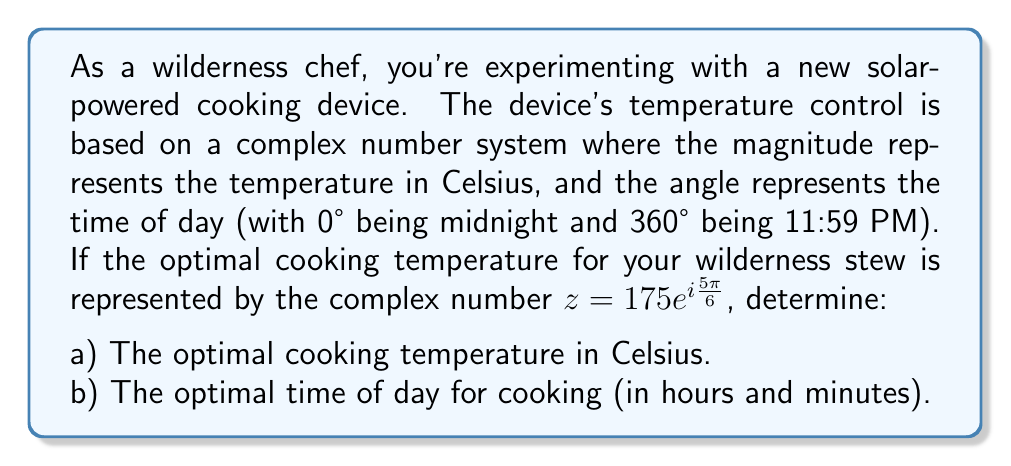Show me your answer to this math problem. Let's approach this problem step-by-step using the polar form of complex numbers.

1) The given complex number is $z = 175e^{i\frac{5\pi}{6}}$

2) In the polar form $re^{i\theta}$, $r$ represents the magnitude and $\theta$ represents the angle.

3) For part a):
   The magnitude $r = 175$, which directly represents the temperature in Celsius.

4) For part b):
   The angle $\theta = \frac{5\pi}{6}$

   To convert this to time:
   - Full circle (360°) = 24 hours
   - $\frac{5\pi}{6}$ radians = $\frac{5\pi}{6} \cdot \frac{180°}{\pi} = 150°$

   Now, we set up a proportion:
   $$\frac{150°}{x \text{ hours}} = \frac{360°}{24 \text{ hours}}$$

   Cross multiply:
   $$150 \cdot 24 = 360x$$
   $$3600 = 360x$$
   $$x = 10 \text{ hours}$$

   10 hours after midnight is 10:00 AM.

Therefore, the optimal cooking time is 10:00 AM.
Answer: a) The optimal cooking temperature is 175°C.
b) The optimal time of day for cooking is 10:00 AM. 